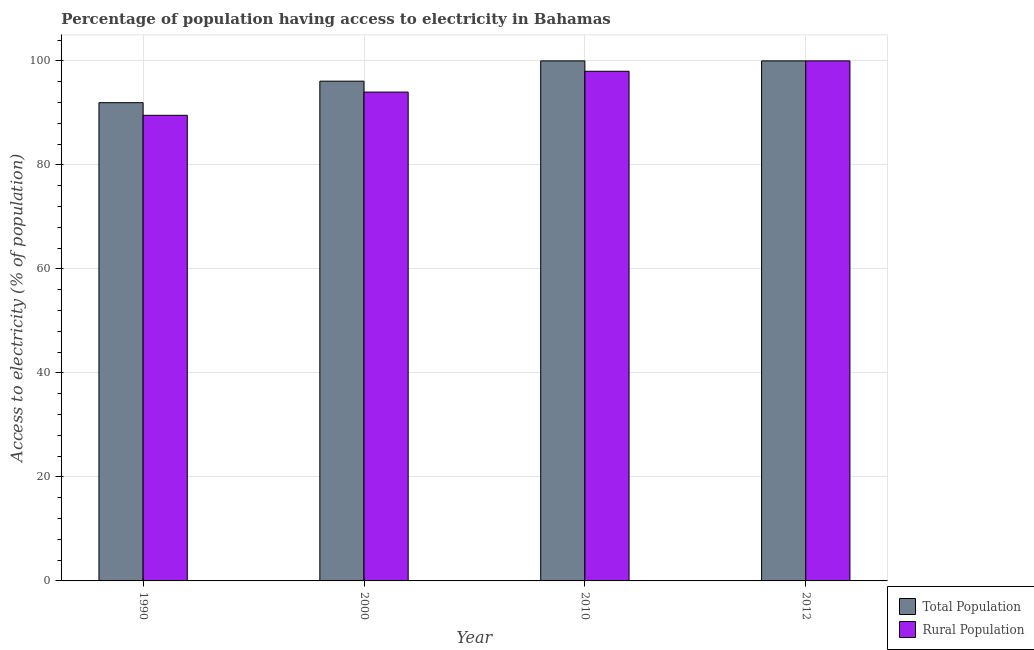Are the number of bars per tick equal to the number of legend labels?
Provide a succinct answer. Yes. Are the number of bars on each tick of the X-axis equal?
Give a very brief answer. Yes. How many bars are there on the 3rd tick from the left?
Ensure brevity in your answer.  2. How many bars are there on the 2nd tick from the right?
Provide a succinct answer. 2. In how many cases, is the number of bars for a given year not equal to the number of legend labels?
Ensure brevity in your answer.  0. Across all years, what is the maximum percentage of population having access to electricity?
Give a very brief answer. 100. Across all years, what is the minimum percentage of rural population having access to electricity?
Offer a terse response. 89.53. In which year was the percentage of population having access to electricity minimum?
Keep it short and to the point. 1990. What is the total percentage of population having access to electricity in the graph?
Give a very brief answer. 388.06. What is the difference between the percentage of rural population having access to electricity in 1990 and that in 2010?
Your answer should be compact. -8.47. What is the difference between the percentage of rural population having access to electricity in 2000 and the percentage of population having access to electricity in 2010?
Offer a terse response. -4. What is the average percentage of population having access to electricity per year?
Ensure brevity in your answer.  97.02. In how many years, is the percentage of rural population having access to electricity greater than 92 %?
Ensure brevity in your answer.  3. Is the percentage of population having access to electricity in 2000 less than that in 2010?
Ensure brevity in your answer.  Yes. What is the difference between the highest and the second highest percentage of rural population having access to electricity?
Your answer should be compact. 2. What is the difference between the highest and the lowest percentage of population having access to electricity?
Make the answer very short. 8.04. In how many years, is the percentage of rural population having access to electricity greater than the average percentage of rural population having access to electricity taken over all years?
Offer a very short reply. 2. Is the sum of the percentage of population having access to electricity in 2010 and 2012 greater than the maximum percentage of rural population having access to electricity across all years?
Give a very brief answer. Yes. What does the 1st bar from the left in 1990 represents?
Offer a very short reply. Total Population. What does the 1st bar from the right in 2012 represents?
Provide a short and direct response. Rural Population. How many bars are there?
Keep it short and to the point. 8. How many years are there in the graph?
Provide a succinct answer. 4. What is the difference between two consecutive major ticks on the Y-axis?
Give a very brief answer. 20. Does the graph contain any zero values?
Ensure brevity in your answer.  No. How many legend labels are there?
Ensure brevity in your answer.  2. How are the legend labels stacked?
Provide a short and direct response. Vertical. What is the title of the graph?
Your response must be concise. Percentage of population having access to electricity in Bahamas. Does "Domestic Liabilities" appear as one of the legend labels in the graph?
Provide a succinct answer. No. What is the label or title of the Y-axis?
Your answer should be compact. Access to electricity (% of population). What is the Access to electricity (% of population) of Total Population in 1990?
Give a very brief answer. 91.96. What is the Access to electricity (% of population) in Rural Population in 1990?
Your answer should be compact. 89.53. What is the Access to electricity (% of population) of Total Population in 2000?
Make the answer very short. 96.1. What is the Access to electricity (% of population) in Rural Population in 2000?
Give a very brief answer. 94. What is the Access to electricity (% of population) in Total Population in 2010?
Keep it short and to the point. 100. Across all years, what is the minimum Access to electricity (% of population) in Total Population?
Your answer should be compact. 91.96. Across all years, what is the minimum Access to electricity (% of population) in Rural Population?
Keep it short and to the point. 89.53. What is the total Access to electricity (% of population) of Total Population in the graph?
Make the answer very short. 388.06. What is the total Access to electricity (% of population) of Rural Population in the graph?
Ensure brevity in your answer.  381.53. What is the difference between the Access to electricity (% of population) of Total Population in 1990 and that in 2000?
Offer a terse response. -4.14. What is the difference between the Access to electricity (% of population) of Rural Population in 1990 and that in 2000?
Offer a very short reply. -4.47. What is the difference between the Access to electricity (% of population) of Total Population in 1990 and that in 2010?
Give a very brief answer. -8.04. What is the difference between the Access to electricity (% of population) in Rural Population in 1990 and that in 2010?
Your answer should be very brief. -8.47. What is the difference between the Access to electricity (% of population) of Total Population in 1990 and that in 2012?
Ensure brevity in your answer.  -8.04. What is the difference between the Access to electricity (% of population) in Rural Population in 1990 and that in 2012?
Offer a terse response. -10.47. What is the difference between the Access to electricity (% of population) of Rural Population in 2000 and that in 2010?
Offer a very short reply. -4. What is the difference between the Access to electricity (% of population) of Total Population in 2000 and that in 2012?
Provide a succinct answer. -3.9. What is the difference between the Access to electricity (% of population) of Rural Population in 2000 and that in 2012?
Provide a short and direct response. -6. What is the difference between the Access to electricity (% of population) in Total Population in 2010 and that in 2012?
Provide a short and direct response. 0. What is the difference between the Access to electricity (% of population) of Rural Population in 2010 and that in 2012?
Your response must be concise. -2. What is the difference between the Access to electricity (% of population) of Total Population in 1990 and the Access to electricity (% of population) of Rural Population in 2000?
Offer a very short reply. -2.04. What is the difference between the Access to electricity (% of population) in Total Population in 1990 and the Access to electricity (% of population) in Rural Population in 2010?
Give a very brief answer. -6.04. What is the difference between the Access to electricity (% of population) in Total Population in 1990 and the Access to electricity (% of population) in Rural Population in 2012?
Keep it short and to the point. -8.04. What is the average Access to electricity (% of population) in Total Population per year?
Your answer should be very brief. 97.02. What is the average Access to electricity (% of population) in Rural Population per year?
Provide a succinct answer. 95.38. In the year 1990, what is the difference between the Access to electricity (% of population) of Total Population and Access to electricity (% of population) of Rural Population?
Offer a very short reply. 2.43. In the year 2000, what is the difference between the Access to electricity (% of population) of Total Population and Access to electricity (% of population) of Rural Population?
Offer a very short reply. 2.1. What is the ratio of the Access to electricity (% of population) of Total Population in 1990 to that in 2000?
Ensure brevity in your answer.  0.96. What is the ratio of the Access to electricity (% of population) in Rural Population in 1990 to that in 2000?
Your answer should be compact. 0.95. What is the ratio of the Access to electricity (% of population) in Total Population in 1990 to that in 2010?
Your answer should be very brief. 0.92. What is the ratio of the Access to electricity (% of population) of Rural Population in 1990 to that in 2010?
Provide a succinct answer. 0.91. What is the ratio of the Access to electricity (% of population) of Total Population in 1990 to that in 2012?
Your response must be concise. 0.92. What is the ratio of the Access to electricity (% of population) of Rural Population in 1990 to that in 2012?
Provide a short and direct response. 0.9. What is the ratio of the Access to electricity (% of population) of Total Population in 2000 to that in 2010?
Offer a very short reply. 0.96. What is the ratio of the Access to electricity (% of population) in Rural Population in 2000 to that in 2010?
Offer a very short reply. 0.96. What is the ratio of the Access to electricity (% of population) of Total Population in 2000 to that in 2012?
Keep it short and to the point. 0.96. What is the difference between the highest and the second highest Access to electricity (% of population) in Total Population?
Ensure brevity in your answer.  0. What is the difference between the highest and the second highest Access to electricity (% of population) in Rural Population?
Offer a very short reply. 2. What is the difference between the highest and the lowest Access to electricity (% of population) in Total Population?
Your answer should be compact. 8.04. What is the difference between the highest and the lowest Access to electricity (% of population) in Rural Population?
Your answer should be very brief. 10.47. 